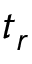Convert formula to latex. <formula><loc_0><loc_0><loc_500><loc_500>t _ { r }</formula> 